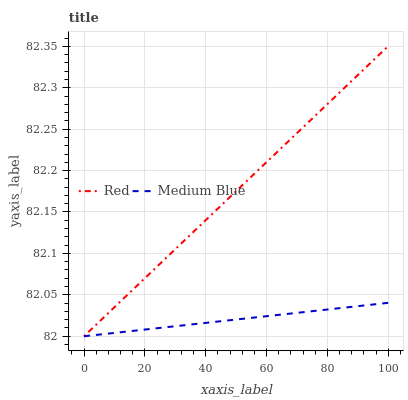Does Medium Blue have the minimum area under the curve?
Answer yes or no. Yes. Does Red have the maximum area under the curve?
Answer yes or no. Yes. Does Red have the minimum area under the curve?
Answer yes or no. No. Is Red the smoothest?
Answer yes or no. Yes. Is Medium Blue the roughest?
Answer yes or no. Yes. Is Red the roughest?
Answer yes or no. No. Does Red have the highest value?
Answer yes or no. Yes. Does Medium Blue intersect Red?
Answer yes or no. Yes. Is Medium Blue less than Red?
Answer yes or no. No. Is Medium Blue greater than Red?
Answer yes or no. No. 